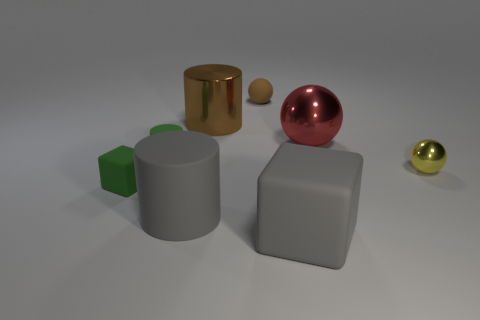There is a tiny sphere that is left of the tiny yellow sphere that is right of the large ball; how many big gray matte objects are in front of it?
Your response must be concise. 2. What size is the green rubber cylinder?
Ensure brevity in your answer.  Small. Is the rubber sphere the same color as the large metallic sphere?
Your answer should be very brief. No. There is a matte cylinder that is in front of the tiny rubber cylinder; what is its size?
Make the answer very short. Large. There is a rubber block on the left side of the big rubber block; is its color the same as the matte block in front of the small green rubber cube?
Offer a very short reply. No. How many other things are the same shape as the small brown thing?
Provide a short and direct response. 2. Is the number of small yellow metal things left of the small rubber cylinder the same as the number of big red objects to the right of the big ball?
Offer a very short reply. Yes. Do the green thing that is on the right side of the green matte block and the gray thing that is in front of the gray matte cylinder have the same material?
Make the answer very short. Yes. How many other things are there of the same size as the green matte cylinder?
Your answer should be very brief. 3. What number of things are brown metallic cylinders or gray blocks that are in front of the gray matte cylinder?
Your response must be concise. 2. 